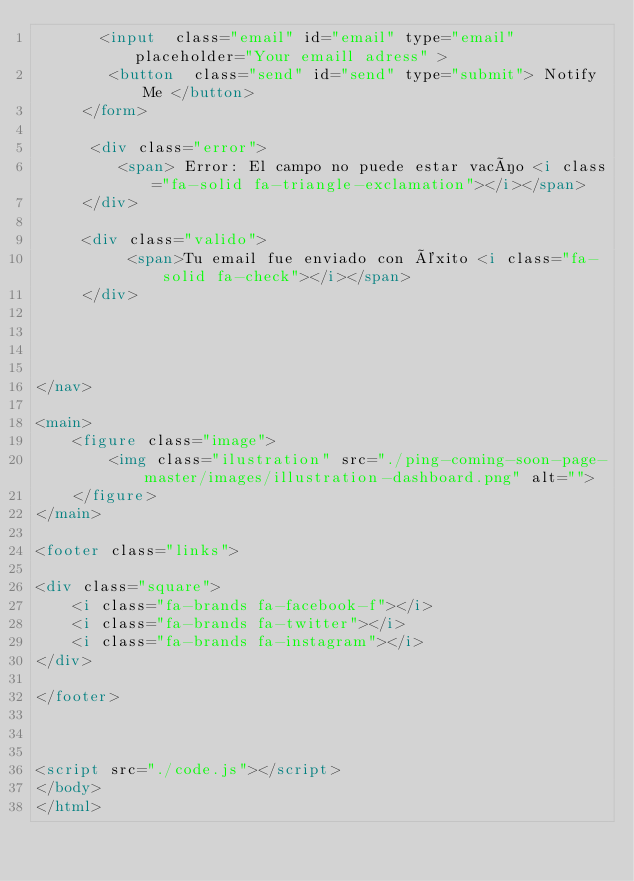<code> <loc_0><loc_0><loc_500><loc_500><_HTML_>       <input  class="email" id="email" type="email" placeholder="Your emaill adress" >
        <button  class="send" id="send" type="submit"> Notify Me </button>
     </form>
     
      <div class="error">
         <span> Error: El campo no puede estar vacío <i class="fa-solid fa-triangle-exclamation"></i></span>
     </div> 

     <div class="valido">
          <span>Tu email fue enviado con éxito <i class="fa-solid fa-check"></i></span>
     </div>




</nav>

<main>
    <figure class="image">
        <img class="ilustration" src="./ping-coming-soon-page-master/images/illustration-dashboard.png" alt="">
    </figure>
</main>

<footer class="links">

<div class="square">
    <i class="fa-brands fa-facebook-f"></i>
    <i class="fa-brands fa-twitter"></i>
    <i class="fa-brands fa-instagram"></i>
</div>

</footer>



<script src="./code.js"></script>
</body>
</html></code> 